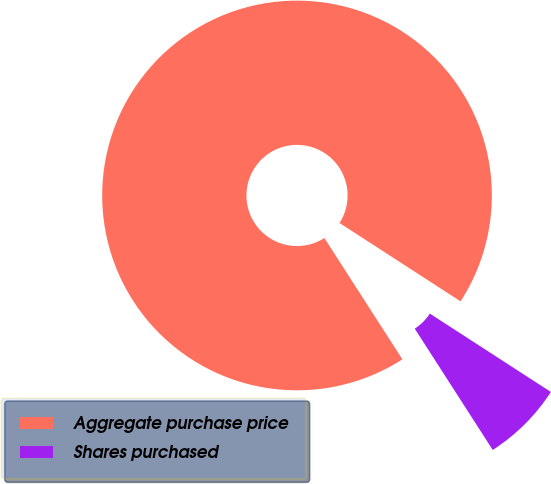Convert chart to OTSL. <chart><loc_0><loc_0><loc_500><loc_500><pie_chart><fcel>Aggregate purchase price<fcel>Shares purchased<nl><fcel>93.24%<fcel>6.76%<nl></chart> 